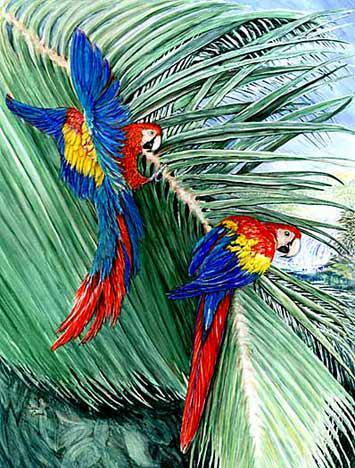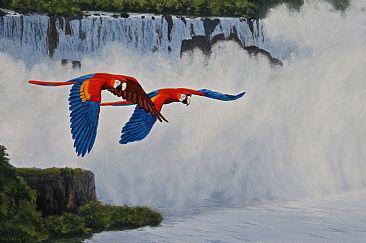The first image is the image on the left, the second image is the image on the right. Examine the images to the left and right. Is the description "There are no more than 2 birds in each image." accurate? Answer yes or no. Yes. 